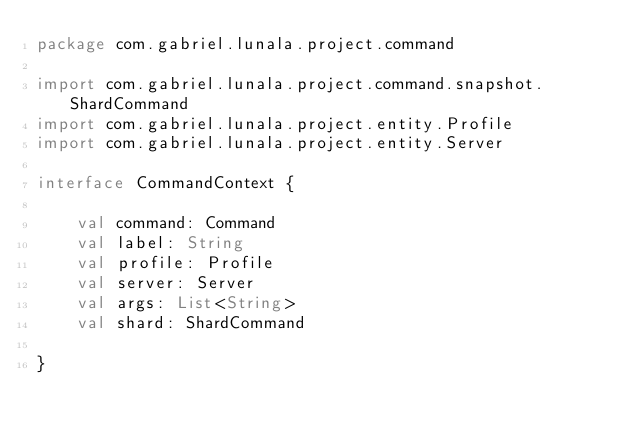Convert code to text. <code><loc_0><loc_0><loc_500><loc_500><_Kotlin_>package com.gabriel.lunala.project.command

import com.gabriel.lunala.project.command.snapshot.ShardCommand
import com.gabriel.lunala.project.entity.Profile
import com.gabriel.lunala.project.entity.Server

interface CommandContext {

    val command: Command
    val label: String
    val profile: Profile
    val server: Server
    val args: List<String>
    val shard: ShardCommand

}</code> 